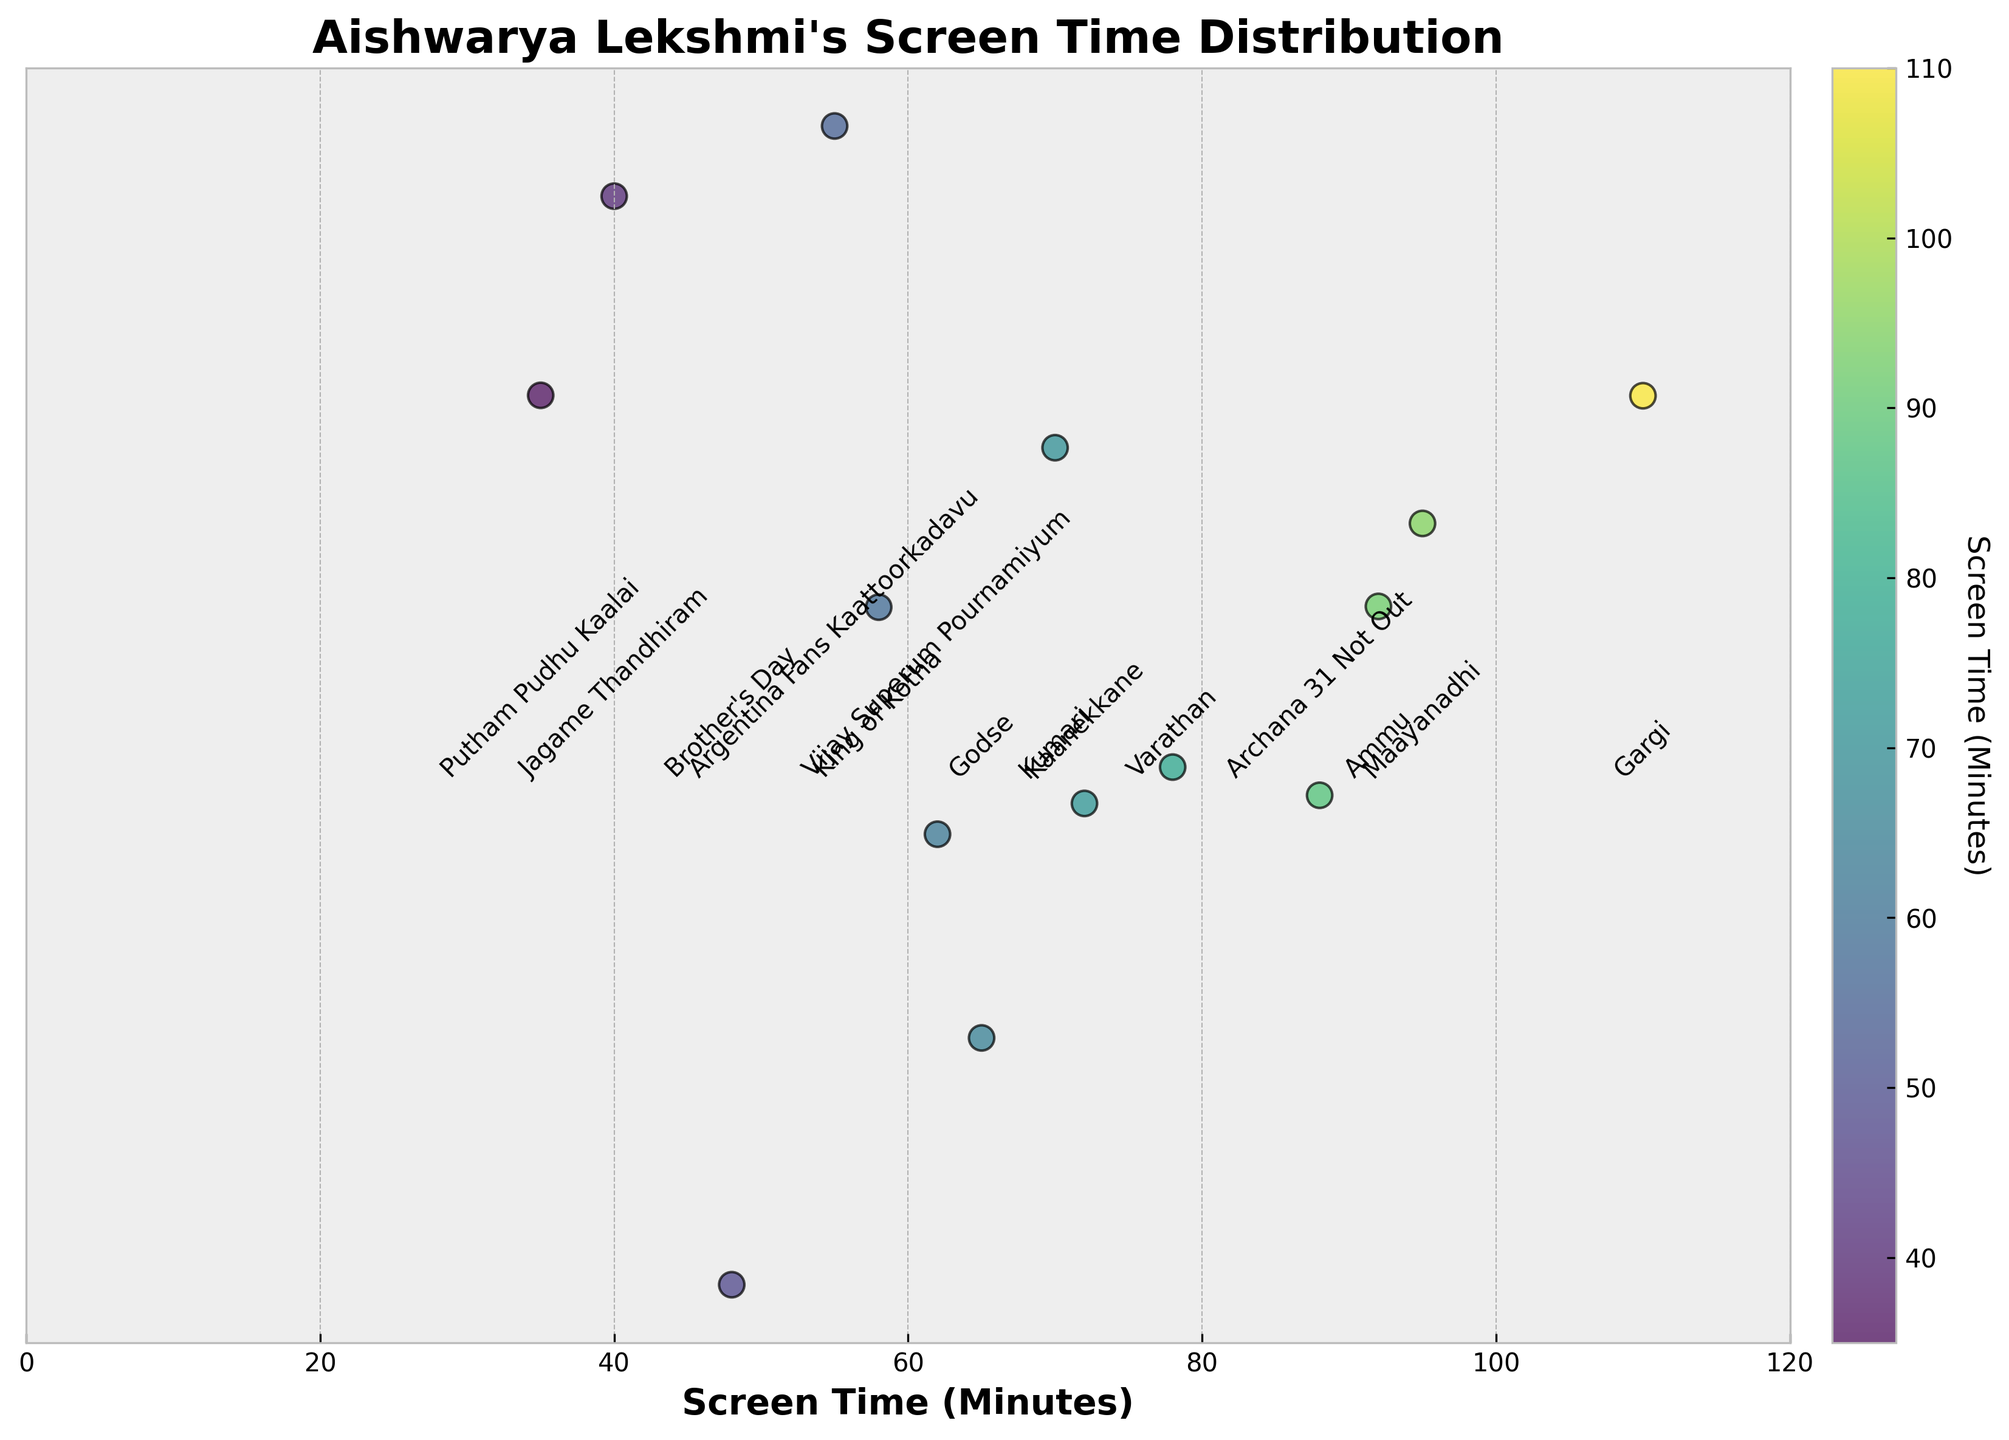What's the title of the plot? The title of the plot is located at the top of the figure, in bold. It indicates the subject of the data being visualized.
Answer: Aishwarya Lekshmi's Screen Time Distribution What is the longest screen time Aishwarya Lekshmi has for a movie role? By observing the x-axis and identifying the farthest point on the right, which is then labeled, we can find the longest screen time.
Answer: 110 minutes Which movie has the shortest screen time? By checking the points at the lowest end of the x-axis, we can identify the corresponding movie from the annotation.
Answer: Putham Pudhu Kaalai How many movies have a screen time greater than 70 minutes? Count the points scattered to the right of the 70-minute mark on the x-axis. “Maayanadhi”, “Varathan”, “Gargi” etc., are among these.
Answer: 6 What is the average screen time of Aishwarya Lekshmi's roles in these movies? Sum all the screen times and divide by the number of movies. (95 + 78 + 62 + 55 + 48 + 110 + 88 + 72 + 35 + 40 + 65 + 58 + 92 + 70) / 14 = 63.86
Answer: 63.86 minutes Which movie has a screen time exactly at the midpoint between the shortest and longest screen times? First find the midpoint: (35 + 110) / 2 = 72.5, then look for the screen time closest to this value.
Answer: Kaanekkane (72 minutes) Compare the screen time of “Gargi” with “Putham Pudhu Kaalai”; how many times is “Gargi” longer? Divide the screen time of “Gargi” by that of “Putham Pudhu Kaalai”. 110 / 35 ≈ 3.14
Answer: Approximately 3.14 times longer What color is predominantly used for the movies with the highest screen times? The color bar on the right of the plot uses a gradient, which can be compared to the scatter plot colors next to higher screen times.
Answer: Darker green Is there a movie with a screen time of exactly 65 minutes? If yes, which one? Check for a scattered point exactly at 65 minutes on the x-axis and read the annotation.
Answer: Yes, Godse What is the range of screen times for Aishwarya Lekshmi's roles? Calculate the difference between the maximum and minimum screen times plotted on the x-axis. 110 (Gargi) - 35 (Putham Pudhu Kaalai) = 75
Answer: 75 minutes 